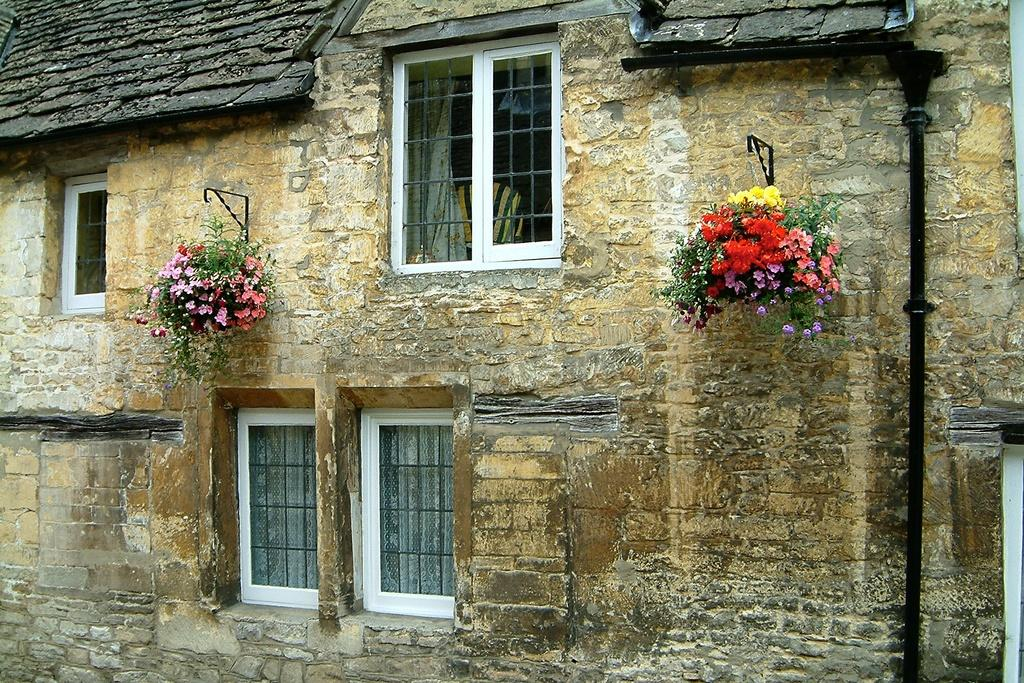What type of structure is present in the image? There is a building in the image. What feature can be seen on the building? The building has windows. What type of vegetation is present in the image? There are house plants and flowers visible in the image. Can you describe an object on the right side of the image? There is a rod on the right side of the image. What type of cattle can be seen grazing in the image? There is no cattle present in the image; it features a building, house plants, flowers, and a rod. What type of art is displayed on the walls of the building in the image? There is no information about any art displayed on the walls of the building in the image. 